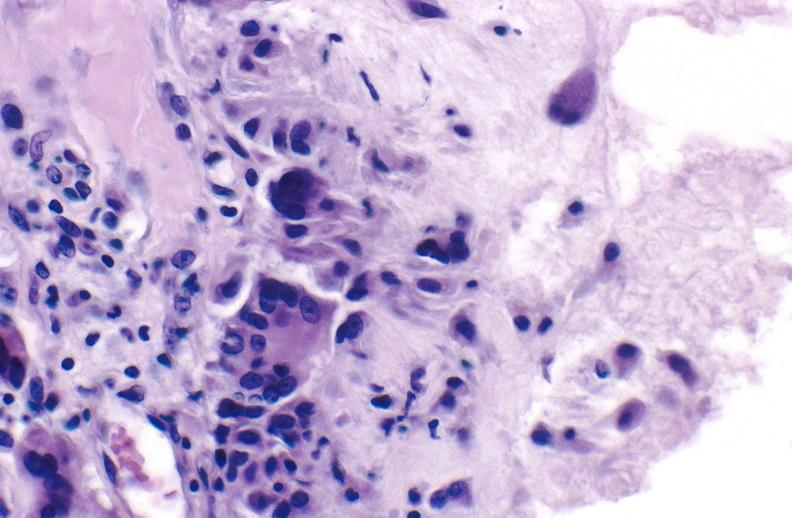does adrenal show gout?
Answer the question using a single word or phrase. No 